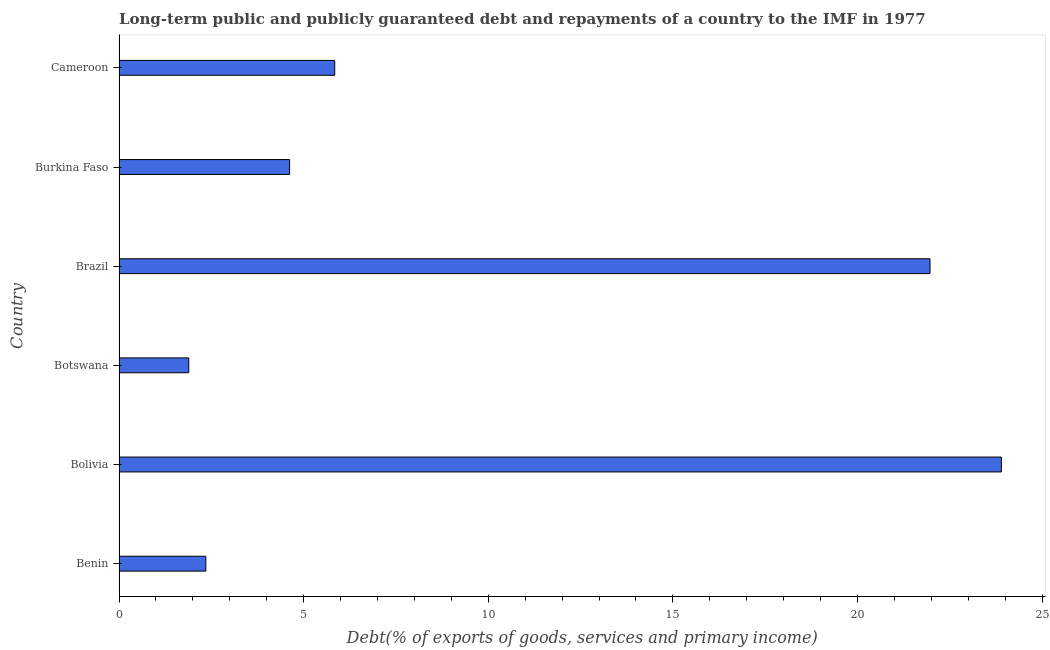Does the graph contain any zero values?
Give a very brief answer. No. Does the graph contain grids?
Offer a very short reply. No. What is the title of the graph?
Keep it short and to the point. Long-term public and publicly guaranteed debt and repayments of a country to the IMF in 1977. What is the label or title of the X-axis?
Your response must be concise. Debt(% of exports of goods, services and primary income). What is the label or title of the Y-axis?
Provide a succinct answer. Country. What is the debt service in Benin?
Provide a short and direct response. 2.35. Across all countries, what is the maximum debt service?
Keep it short and to the point. 23.9. Across all countries, what is the minimum debt service?
Keep it short and to the point. 1.89. In which country was the debt service maximum?
Your answer should be compact. Bolivia. In which country was the debt service minimum?
Give a very brief answer. Botswana. What is the sum of the debt service?
Provide a short and direct response. 60.56. What is the difference between the debt service in Bolivia and Cameroon?
Your response must be concise. 18.06. What is the average debt service per country?
Your response must be concise. 10.09. What is the median debt service?
Your answer should be very brief. 5.23. In how many countries, is the debt service greater than 6 %?
Offer a terse response. 2. What is the ratio of the debt service in Benin to that in Botswana?
Give a very brief answer. 1.25. What is the difference between the highest and the second highest debt service?
Offer a very short reply. 1.93. What is the difference between the highest and the lowest debt service?
Give a very brief answer. 22.01. In how many countries, is the debt service greater than the average debt service taken over all countries?
Ensure brevity in your answer.  2. Are all the bars in the graph horizontal?
Provide a short and direct response. Yes. How many countries are there in the graph?
Your response must be concise. 6. What is the difference between two consecutive major ticks on the X-axis?
Keep it short and to the point. 5. Are the values on the major ticks of X-axis written in scientific E-notation?
Give a very brief answer. No. What is the Debt(% of exports of goods, services and primary income) of Benin?
Your response must be concise. 2.35. What is the Debt(% of exports of goods, services and primary income) of Bolivia?
Provide a short and direct response. 23.9. What is the Debt(% of exports of goods, services and primary income) of Botswana?
Keep it short and to the point. 1.89. What is the Debt(% of exports of goods, services and primary income) in Brazil?
Make the answer very short. 21.96. What is the Debt(% of exports of goods, services and primary income) of Burkina Faso?
Provide a succinct answer. 4.62. What is the Debt(% of exports of goods, services and primary income) in Cameroon?
Provide a short and direct response. 5.84. What is the difference between the Debt(% of exports of goods, services and primary income) in Benin and Bolivia?
Offer a terse response. -21.55. What is the difference between the Debt(% of exports of goods, services and primary income) in Benin and Botswana?
Ensure brevity in your answer.  0.46. What is the difference between the Debt(% of exports of goods, services and primary income) in Benin and Brazil?
Ensure brevity in your answer.  -19.61. What is the difference between the Debt(% of exports of goods, services and primary income) in Benin and Burkina Faso?
Provide a short and direct response. -2.27. What is the difference between the Debt(% of exports of goods, services and primary income) in Benin and Cameroon?
Offer a very short reply. -3.49. What is the difference between the Debt(% of exports of goods, services and primary income) in Bolivia and Botswana?
Keep it short and to the point. 22.01. What is the difference between the Debt(% of exports of goods, services and primary income) in Bolivia and Brazil?
Keep it short and to the point. 1.93. What is the difference between the Debt(% of exports of goods, services and primary income) in Bolivia and Burkina Faso?
Your answer should be very brief. 19.28. What is the difference between the Debt(% of exports of goods, services and primary income) in Bolivia and Cameroon?
Keep it short and to the point. 18.06. What is the difference between the Debt(% of exports of goods, services and primary income) in Botswana and Brazil?
Offer a very short reply. -20.08. What is the difference between the Debt(% of exports of goods, services and primary income) in Botswana and Burkina Faso?
Provide a succinct answer. -2.73. What is the difference between the Debt(% of exports of goods, services and primary income) in Botswana and Cameroon?
Your answer should be compact. -3.95. What is the difference between the Debt(% of exports of goods, services and primary income) in Brazil and Burkina Faso?
Offer a very short reply. 17.35. What is the difference between the Debt(% of exports of goods, services and primary income) in Brazil and Cameroon?
Make the answer very short. 16.12. What is the difference between the Debt(% of exports of goods, services and primary income) in Burkina Faso and Cameroon?
Keep it short and to the point. -1.22. What is the ratio of the Debt(% of exports of goods, services and primary income) in Benin to that in Bolivia?
Keep it short and to the point. 0.1. What is the ratio of the Debt(% of exports of goods, services and primary income) in Benin to that in Botswana?
Offer a very short reply. 1.25. What is the ratio of the Debt(% of exports of goods, services and primary income) in Benin to that in Brazil?
Provide a succinct answer. 0.11. What is the ratio of the Debt(% of exports of goods, services and primary income) in Benin to that in Burkina Faso?
Your answer should be compact. 0.51. What is the ratio of the Debt(% of exports of goods, services and primary income) in Benin to that in Cameroon?
Give a very brief answer. 0.4. What is the ratio of the Debt(% of exports of goods, services and primary income) in Bolivia to that in Botswana?
Keep it short and to the point. 12.65. What is the ratio of the Debt(% of exports of goods, services and primary income) in Bolivia to that in Brazil?
Provide a short and direct response. 1.09. What is the ratio of the Debt(% of exports of goods, services and primary income) in Bolivia to that in Burkina Faso?
Ensure brevity in your answer.  5.17. What is the ratio of the Debt(% of exports of goods, services and primary income) in Bolivia to that in Cameroon?
Keep it short and to the point. 4.09. What is the ratio of the Debt(% of exports of goods, services and primary income) in Botswana to that in Brazil?
Offer a terse response. 0.09. What is the ratio of the Debt(% of exports of goods, services and primary income) in Botswana to that in Burkina Faso?
Provide a short and direct response. 0.41. What is the ratio of the Debt(% of exports of goods, services and primary income) in Botswana to that in Cameroon?
Make the answer very short. 0.32. What is the ratio of the Debt(% of exports of goods, services and primary income) in Brazil to that in Burkina Faso?
Make the answer very short. 4.75. What is the ratio of the Debt(% of exports of goods, services and primary income) in Brazil to that in Cameroon?
Your answer should be very brief. 3.76. What is the ratio of the Debt(% of exports of goods, services and primary income) in Burkina Faso to that in Cameroon?
Your answer should be compact. 0.79. 